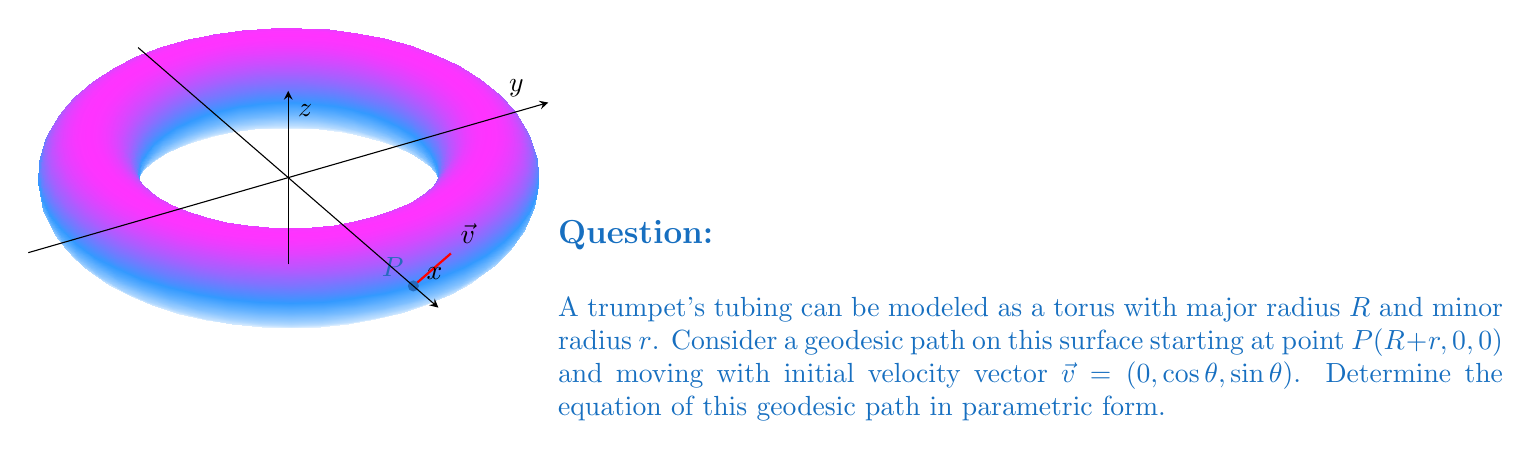What is the answer to this math problem? Let's approach this step-by-step:

1) The parametric equations for a torus with major radius $R$ and minor radius $r$ are:
   $$x = (R + r\cos v)\cos u$$
   $$y = (R + r\cos v)\sin u$$
   $$z = r\sin v$$
   where $0 \leq u, v < 2\pi$

2) The geodesic equations on a torus are given by:
   $$\frac{d^2u}{ds^2} + \frac{2r\sin v}{R + r\cos v}\frac{du}{ds}\frac{dv}{ds} = 0$$
   $$\frac{d^2v}{ds^2} - (R + r\cos v)\cos v\left(\frac{du}{ds}\right)^2 + r\sin v\left(\frac{dv}{ds}\right)^2 = 0$$

3) These equations are complex to solve analytically. However, we can determine the initial conditions and use them to describe the geodesic path.

4) At the starting point $P(R+r, 0, 0)$, we have $u=0$ and $v=0$.

5) The initial velocity vector $\vec{v} = (0, \cos\theta, \sin\theta)$ can be related to the derivatives of $u$ and $v$:
   $$\frac{du}{ds}(0) = \frac{\cos\theta}{R+r}$$
   $$\frac{dv}{ds}(0) = \frac{\sin\theta}{r}$$

6) The geodesic path can be approximated using these initial conditions:
   $$u(s) \approx \frac{\cos\theta}{R+r}s$$
   $$v(s) \approx \frac{\sin\theta}{r}s$$

7) Substituting these into the parametric equations of the torus:
   $$x(s) \approx (R + r\cos(\frac{\sin\theta}{r}s))\cos(\frac{\cos\theta}{R+r}s)$$
   $$y(s) \approx (R + r\cos(\frac{\sin\theta}{r}s))\sin(\frac{\cos\theta}{R+r}s)$$
   $$z(s) \approx r\sin(\frac{\sin\theta}{r}s)$$

These equations approximate the geodesic path on the toroidal surface representing the trumpet's tubing.
Answer: $x(s) \approx (R + r\cos(\frac{\sin\theta}{r}s))\cos(\frac{\cos\theta}{R+r}s)$, $y(s) \approx (R + r\cos(\frac{\sin\theta}{r}s))\sin(\frac{\cos\theta}{R+r}s)$, $z(s) \approx r\sin(\frac{\sin\theta}{r}s)$ 